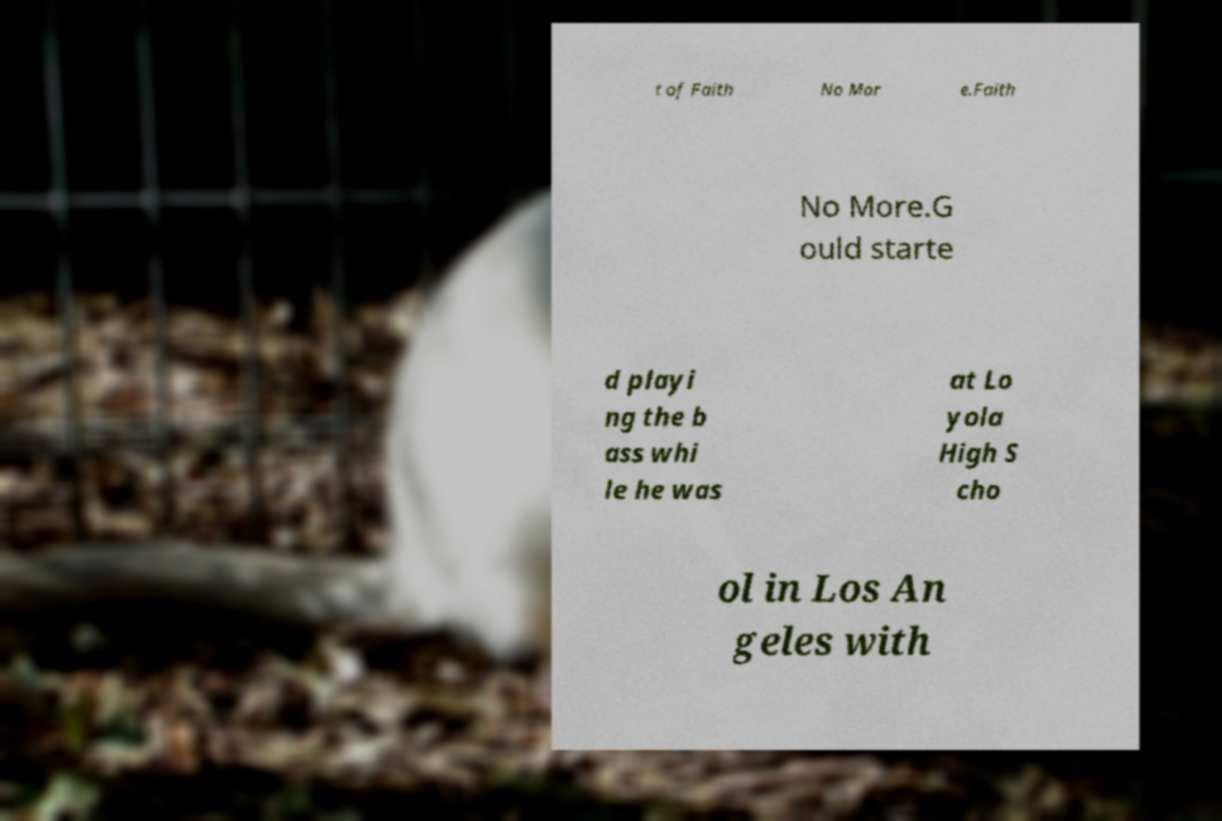For documentation purposes, I need the text within this image transcribed. Could you provide that? t of Faith No Mor e.Faith No More.G ould starte d playi ng the b ass whi le he was at Lo yola High S cho ol in Los An geles with 